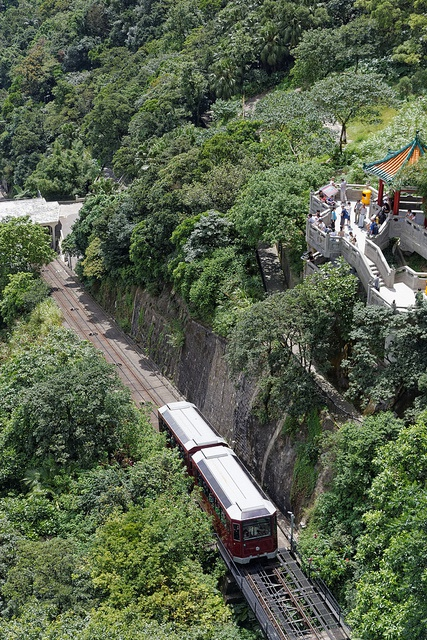Describe the objects in this image and their specific colors. I can see train in gray, white, black, and darkgray tones, people in gray, white, darkgray, and black tones, people in gray and darkgray tones, people in gray, black, and navy tones, and people in gray, navy, lightgray, and darkgray tones in this image. 